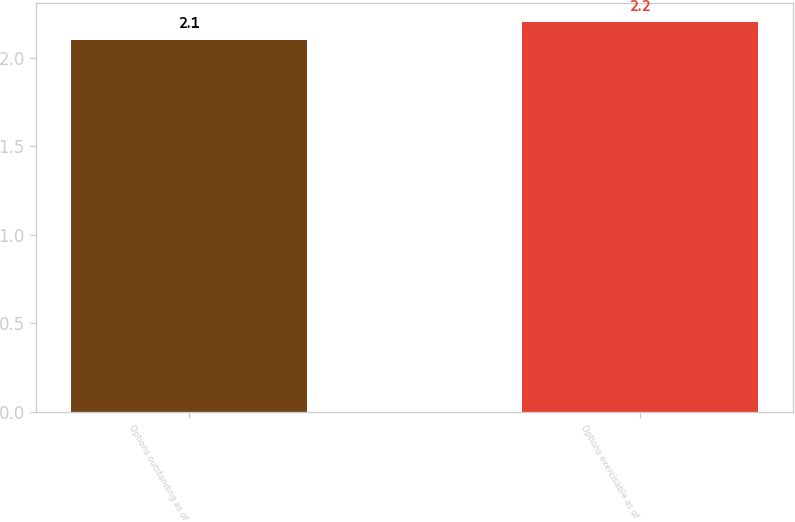Convert chart to OTSL. <chart><loc_0><loc_0><loc_500><loc_500><bar_chart><fcel>Options outstanding as of<fcel>Options exercisable as of<nl><fcel>2.1<fcel>2.2<nl></chart> 